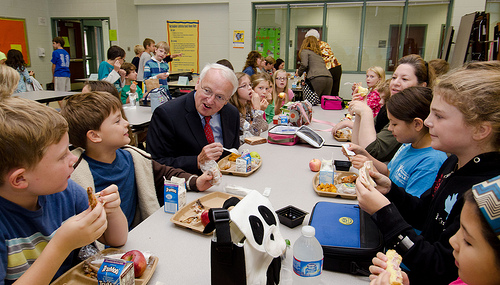<image>
Can you confirm if the box is on the tray? No. The box is not positioned on the tray. They may be near each other, but the box is not supported by or resting on top of the tray. Where is the older man in relation to the panda lunchbox? Is it on the panda lunchbox? No. The older man is not positioned on the panda lunchbox. They may be near each other, but the older man is not supported by or resting on top of the panda lunchbox. Where is the apple in relation to the lunch box? Is it to the left of the lunch box? Yes. From this viewpoint, the apple is positioned to the left side relative to the lunch box. 